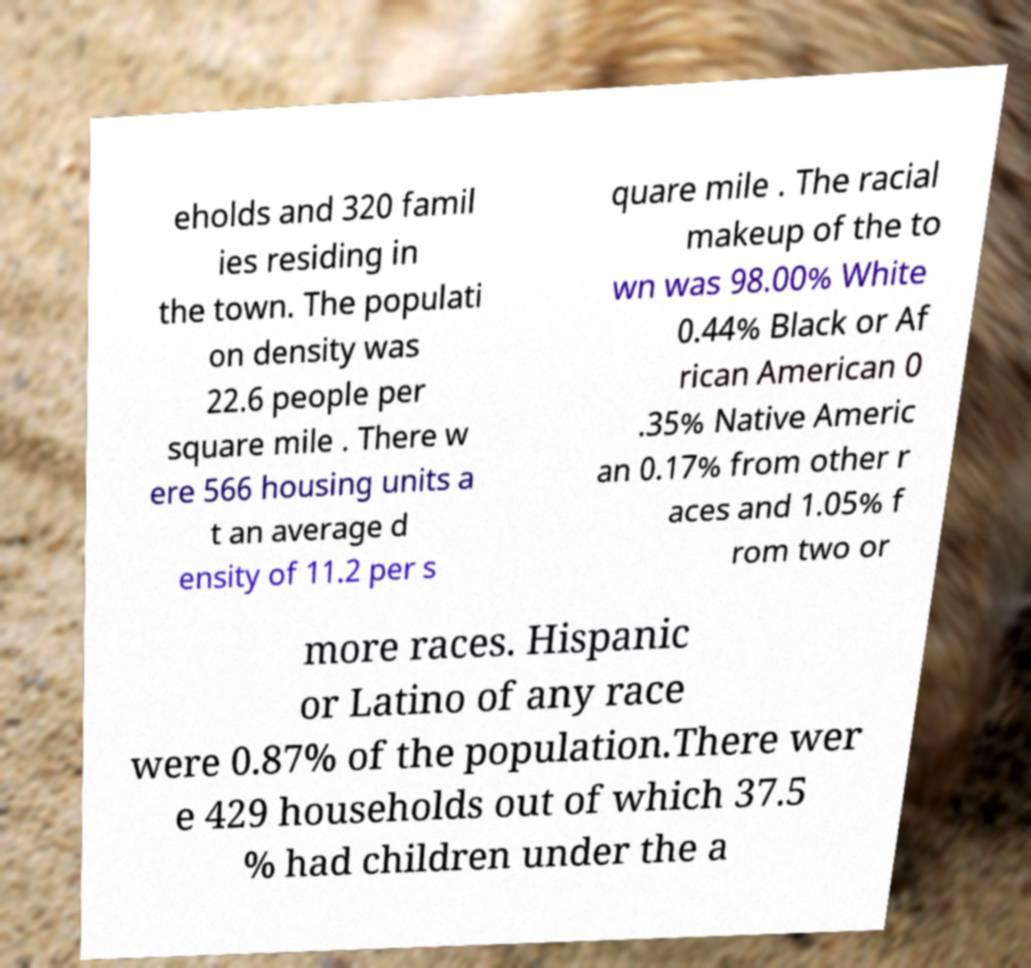Can you read and provide the text displayed in the image?This photo seems to have some interesting text. Can you extract and type it out for me? eholds and 320 famil ies residing in the town. The populati on density was 22.6 people per square mile . There w ere 566 housing units a t an average d ensity of 11.2 per s quare mile . The racial makeup of the to wn was 98.00% White 0.44% Black or Af rican American 0 .35% Native Americ an 0.17% from other r aces and 1.05% f rom two or more races. Hispanic or Latino of any race were 0.87% of the population.There wer e 429 households out of which 37.5 % had children under the a 